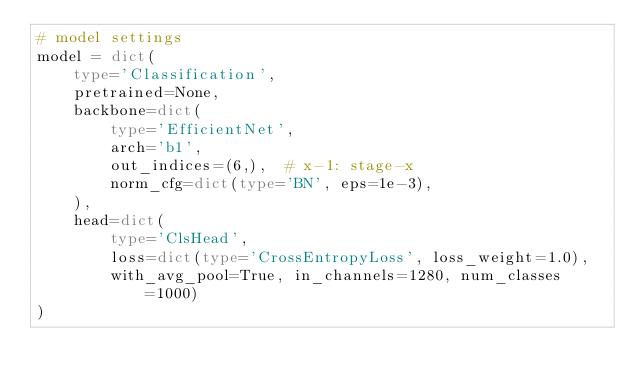Convert code to text. <code><loc_0><loc_0><loc_500><loc_500><_Python_># model settings
model = dict(
    type='Classification',
    pretrained=None,
    backbone=dict(
        type='EfficientNet',
        arch='b1',
        out_indices=(6,),  # x-1: stage-x
        norm_cfg=dict(type='BN', eps=1e-3),
    ),
    head=dict(
        type='ClsHead',
        loss=dict(type='CrossEntropyLoss', loss_weight=1.0),
        with_avg_pool=True, in_channels=1280, num_classes=1000)
)
</code> 